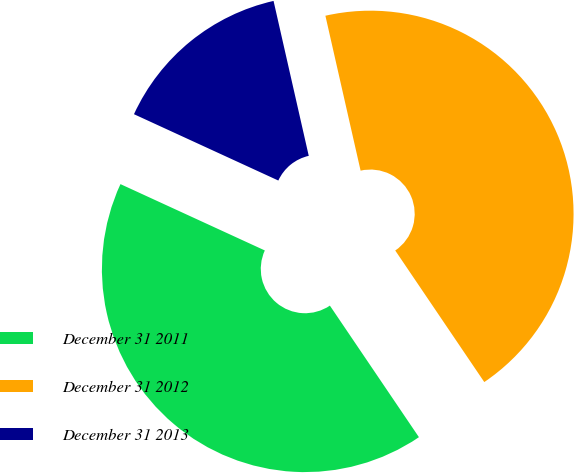Convert chart to OTSL. <chart><loc_0><loc_0><loc_500><loc_500><pie_chart><fcel>December 31 2011<fcel>December 31 2012<fcel>December 31 2013<nl><fcel>41.33%<fcel>44.09%<fcel>14.59%<nl></chart> 